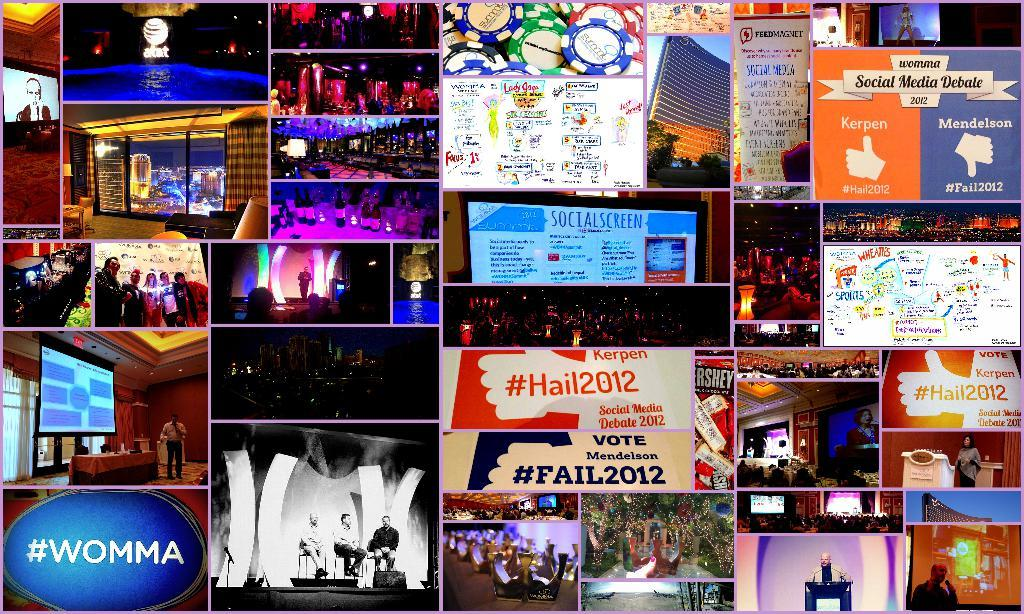<image>
Give a short and clear explanation of the subsequent image. Blue sign in the bottom left reads #WOMMA 